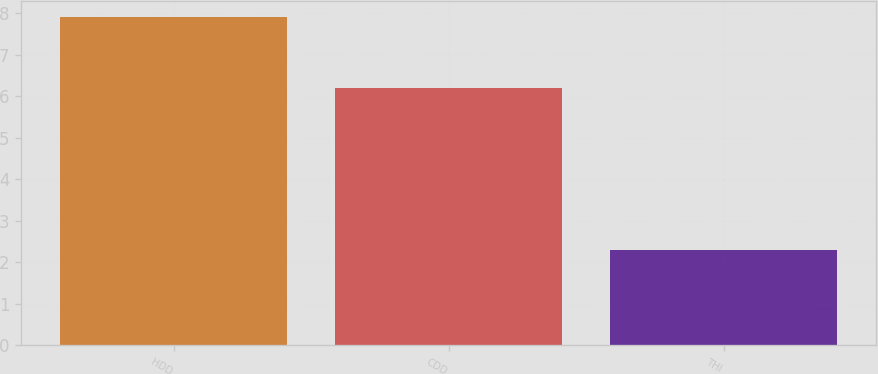Convert chart. <chart><loc_0><loc_0><loc_500><loc_500><bar_chart><fcel>HDD<fcel>CDD<fcel>THI<nl><fcel>7.9<fcel>6.2<fcel>2.3<nl></chart> 